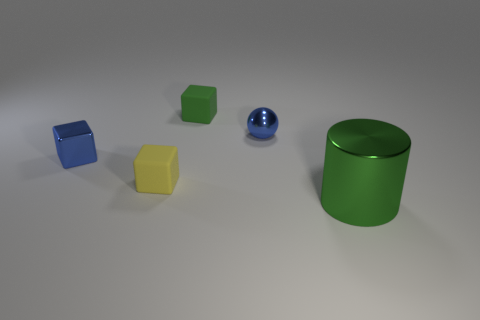Add 3 small blue balls. How many objects exist? 8 Subtract all yellow rubber cubes. How many cubes are left? 2 Subtract all blue blocks. How many blocks are left? 2 Subtract all spheres. How many objects are left? 4 Subtract all cyan cubes. Subtract all yellow spheres. How many cubes are left? 3 Subtract all green matte cubes. Subtract all large blue metal cylinders. How many objects are left? 4 Add 5 green objects. How many green objects are left? 7 Add 1 small shiny spheres. How many small shiny spheres exist? 2 Subtract 0 gray balls. How many objects are left? 5 